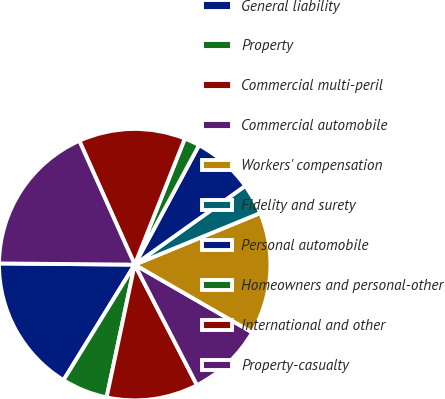Convert chart to OTSL. <chart><loc_0><loc_0><loc_500><loc_500><pie_chart><fcel>General liability<fcel>Property<fcel>Commercial multi-peril<fcel>Commercial automobile<fcel>Workers' compensation<fcel>Fidelity and surety<fcel>Personal automobile<fcel>Homeowners and personal-other<fcel>International and other<fcel>Property-casualty<nl><fcel>16.35%<fcel>5.47%<fcel>10.91%<fcel>9.09%<fcel>14.53%<fcel>3.65%<fcel>7.28%<fcel>1.84%<fcel>12.72%<fcel>18.16%<nl></chart> 